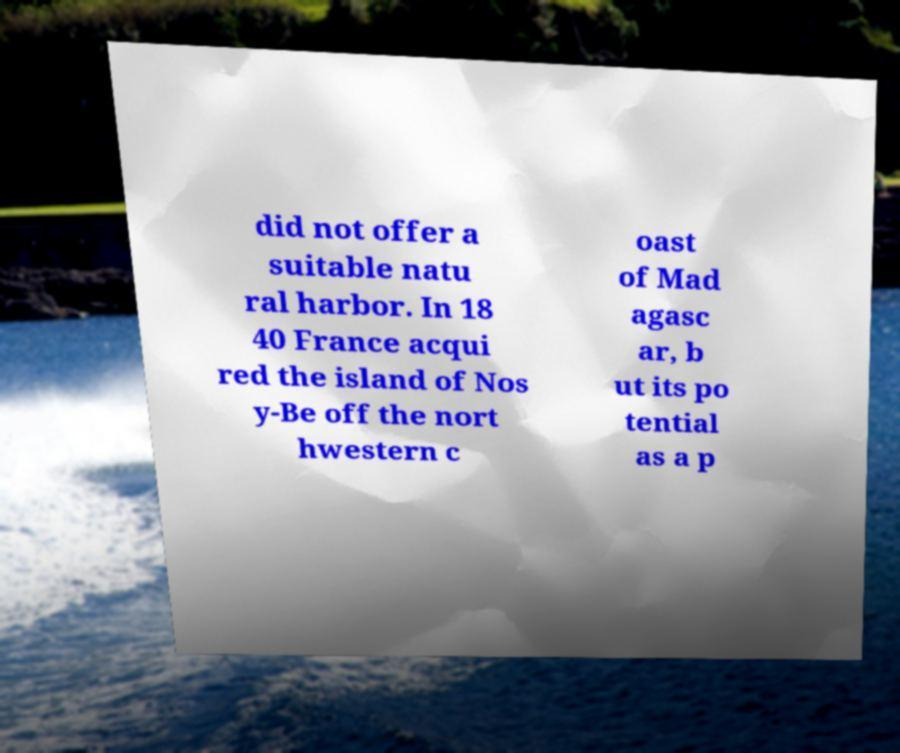Can you accurately transcribe the text from the provided image for me? did not offer a suitable natu ral harbor. In 18 40 France acqui red the island of Nos y-Be off the nort hwestern c oast of Mad agasc ar, b ut its po tential as a p 